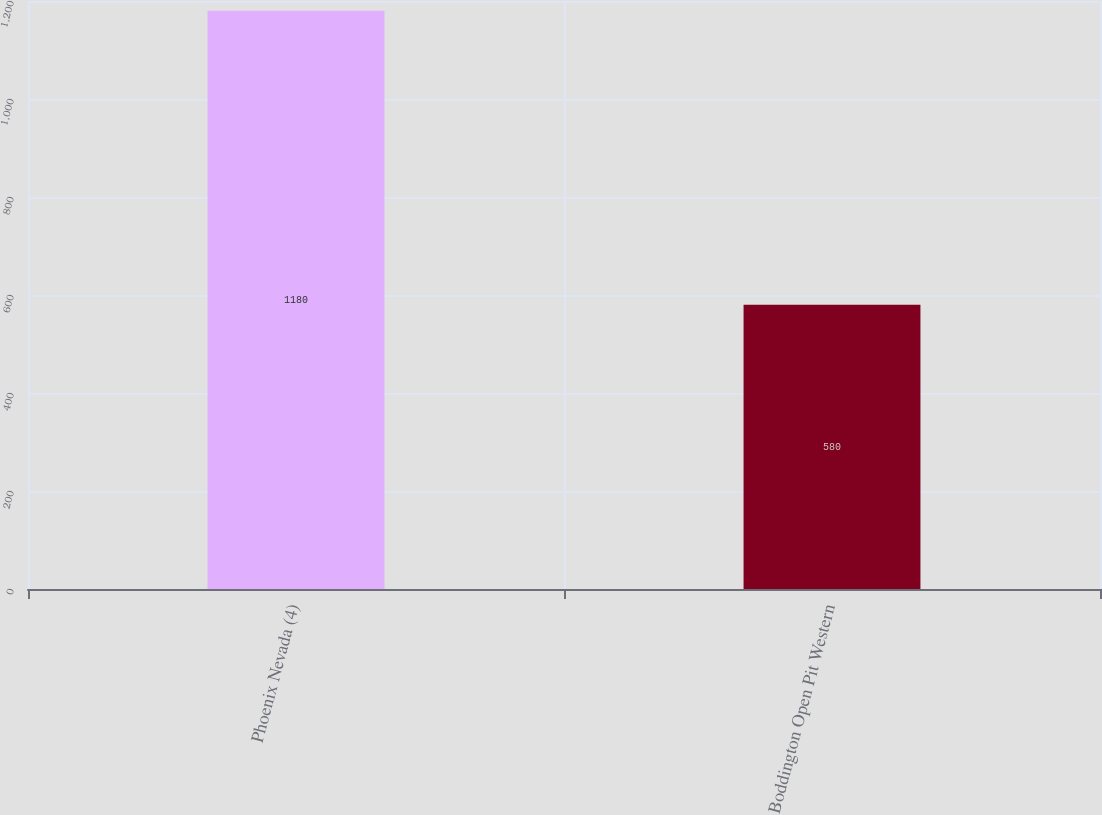Convert chart. <chart><loc_0><loc_0><loc_500><loc_500><bar_chart><fcel>Phoenix Nevada (4)<fcel>Boddington Open Pit Western<nl><fcel>1180<fcel>580<nl></chart> 